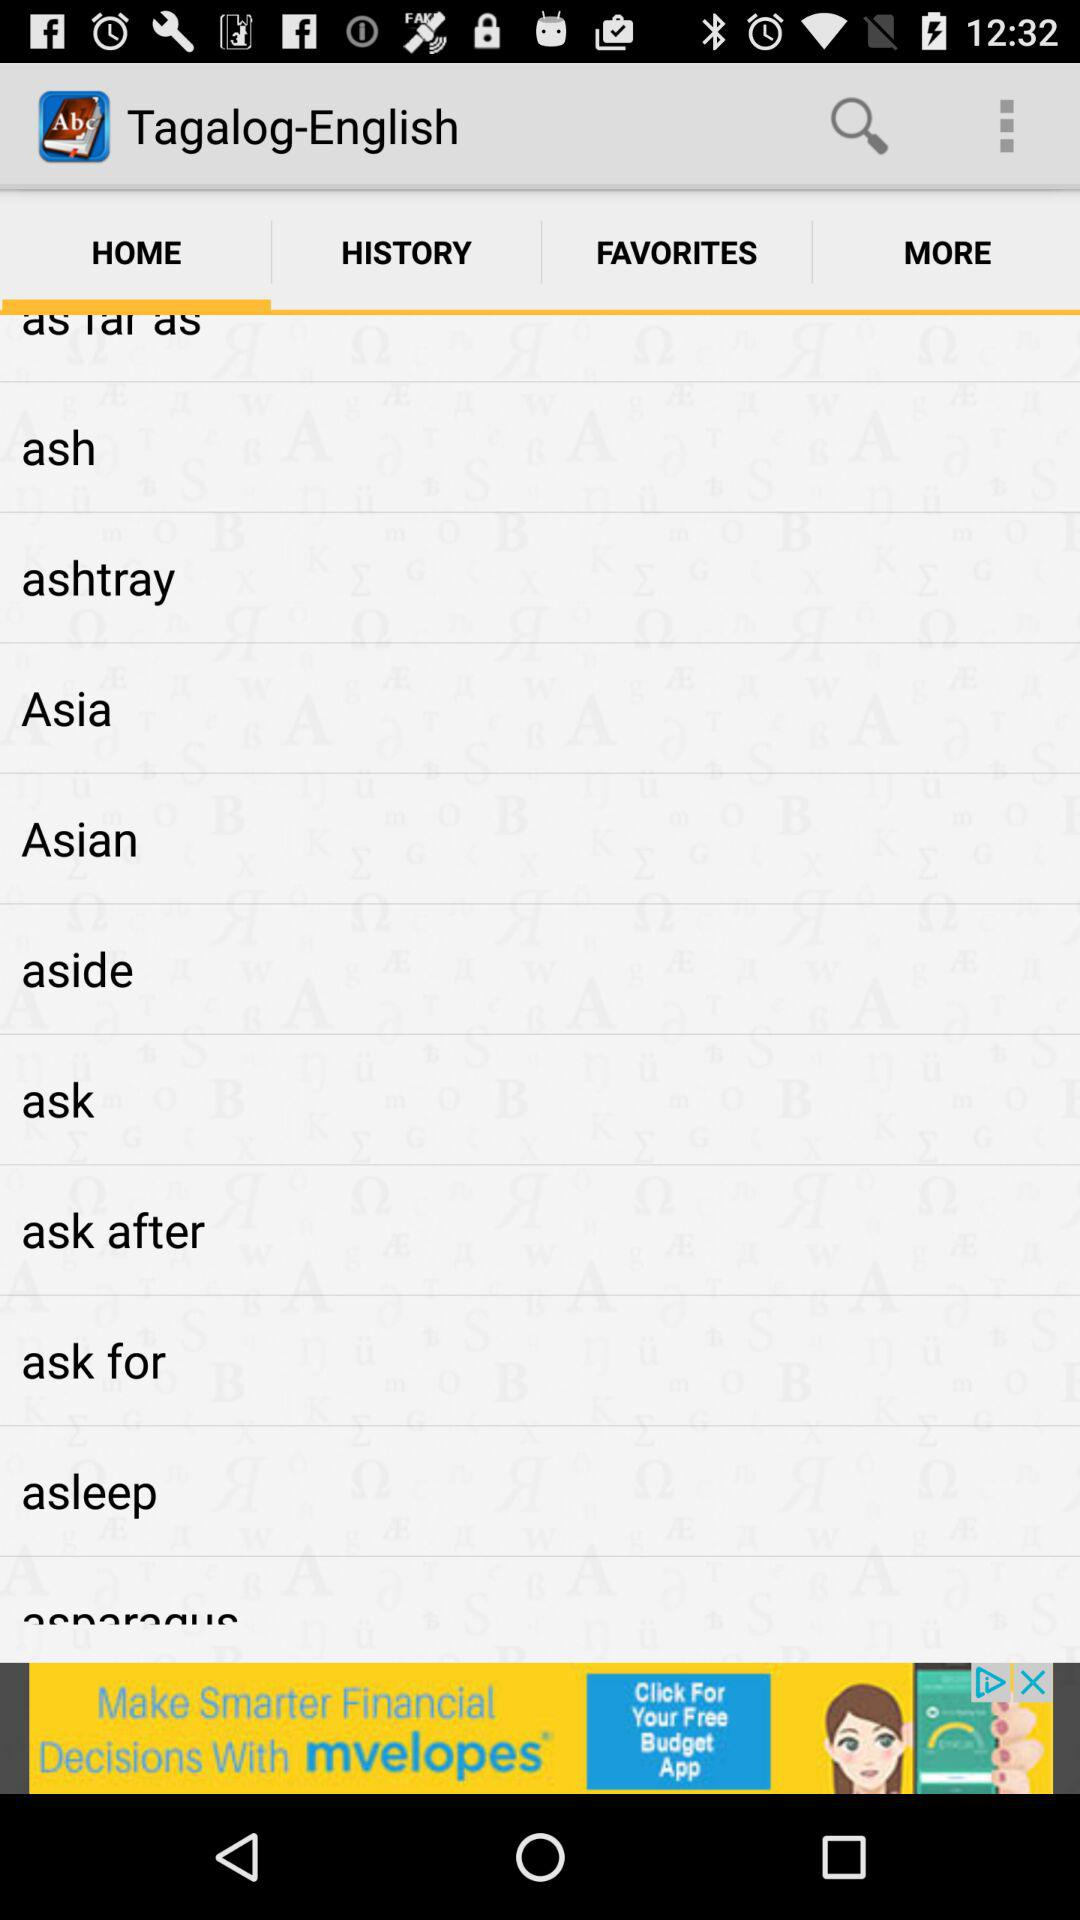What is the name of the application? The name of the application is "Tagalog-English". 